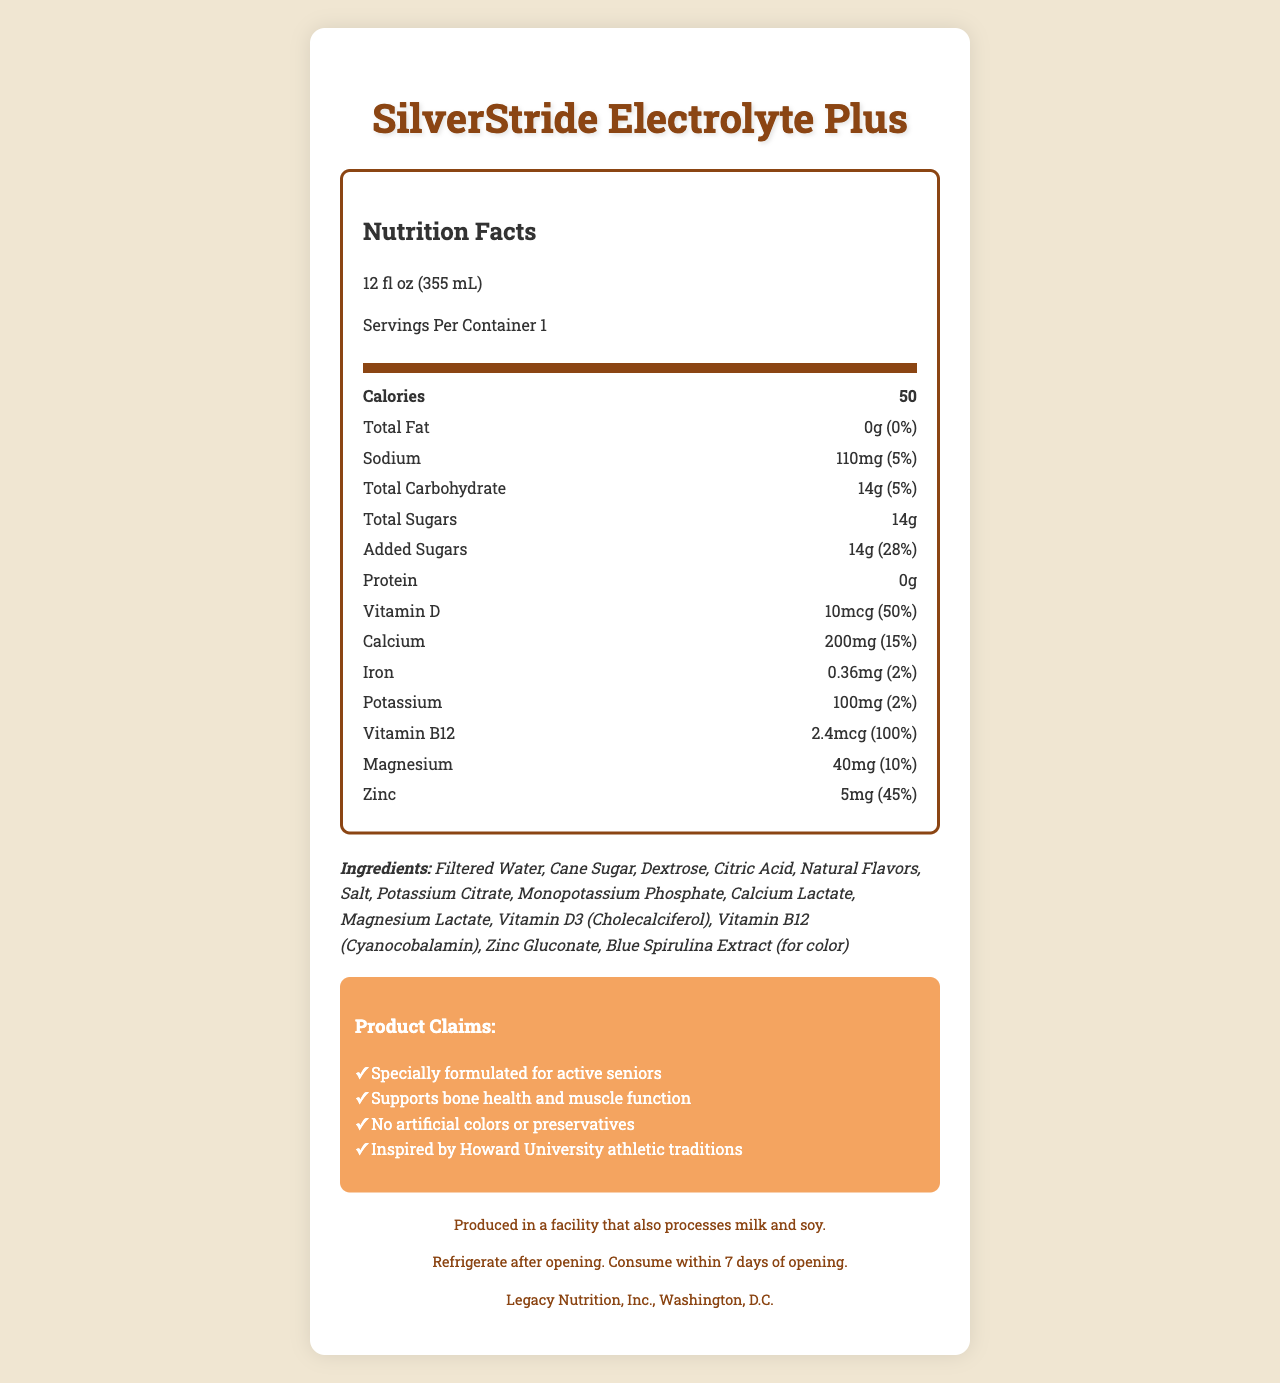what is the product name? The product name is given at the top of the document.
Answer: SilverStride Electrolyte Plus how many servings are there per container? The servings per container is listed as "1" in the Nutrition Facts section.
Answer: 1 what is the sodium content in a single serving? In the Nutrition Facts section, the sodium content is specified as "110mg".
Answer: 110mg what is the amount of vitamin D per serving? The amount of vitamin D per serving is indicated as "10mcg".
Answer: 10mcg how much calcium does a single serving provide? The Nutrition Facts section states that a single serving contains "200mg" of calcium.
Answer: 200mg what is the daily value of added sugars? The added sugars daily value is listed as "28%" in the Nutrition Facts section.
Answer: 28% who manufactures this product? The manufacturer is noted at the bottom of the document.
Answer: Legacy Nutrition, Inc., Washington, D.C. what is the main sweetener used in the drink? Cane Sugar is listed as one of the main ingredients.
Answer: Cane Sugar which vitamin is present at 100% daily value in the drink? The Nutrition Facts section shows Vitamin B12 at a daily value of "100%".
Answer: Vitamin B12 how should the product be stored after opening? The storage instructions specify refrigeration and consumption within 7 days after opening.
Answer: Refrigerate after opening. Consume within 7 days of opening. which mineral provides 15% of its daily value per serving? The daily value for calcium is listed as "15%" in the Nutrition Facts section.
Answer: Calcium how many calories does one serving of the drink contain? The calorie content per serving is noted as "50" in the Nutrition Facts section.
Answer: 50 what is the total carbohydrate content in one serving? A. 10g B. 14g C. 20g D. 0g The total carbohydrate content is listed as "14g".
Answer: B which of the following claims is NOT made by the product? A. Specially formulated for active seniors B. Contains artificial colors C. Supports bone health and muscle function D. Inspired by Howard University athletic traditions The document claims there are no artificial colors or preservatives.
Answer: B does this product contain any protein? The Nutrition Facts section lists protein as "0g", indicating there is no protein.
Answer: No is the product produced in a facility that processes nuts? The allergen information states the product is processed in a facility that handles milk and soy, but does not mention nuts.
Answer: Cannot be determined summarize the document content succinctly. The document includes nutrition information, ingredients, claims, allergen information, storage directions, and the manufacturer's details, all tailored for an older adult audience.
Answer: This document provides detailed nutrition facts for SilverStride Electrolyte Plus, a vitamin-fortified sports drink tailored for seniors. It includes serving size, calorie count, and amounts of key nutrients like sodium, carbohydrates, sugars, vitamins D and B12, calcium, and more. Ingredients, storage instructions, manufacturer information, and product claims are also listed. 